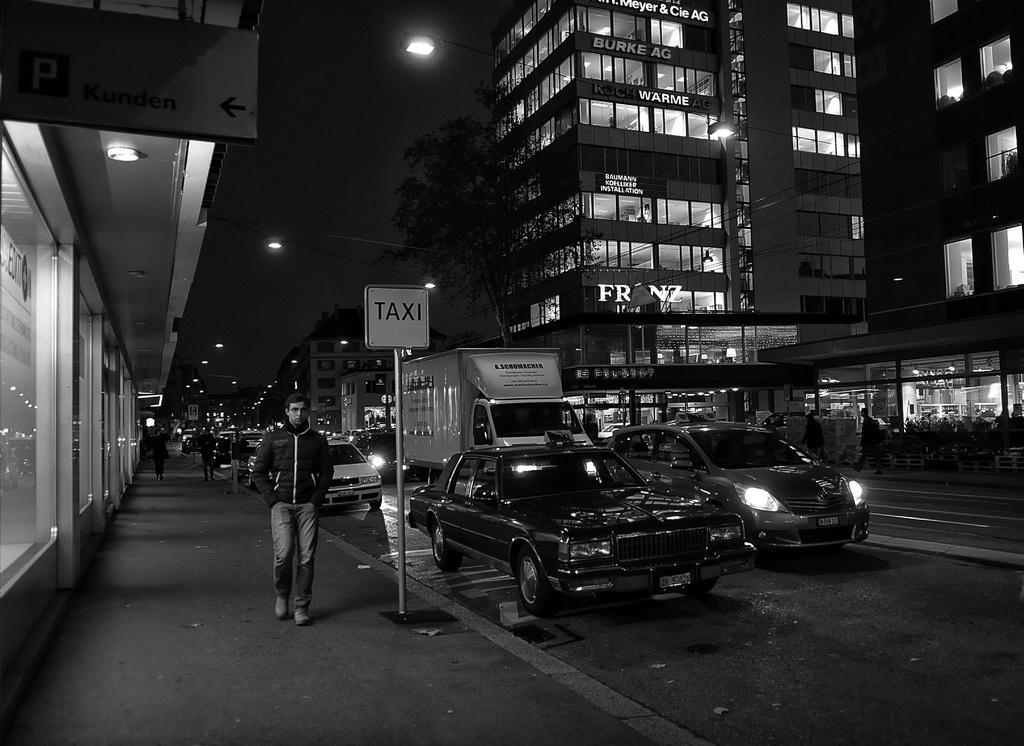Describe this image in one or two sentences. This is an outside view of the city, in this image in the center there are some vehicles on the road. On the right side and left side there are some buildings, trees, lights and some persons are walking on a footpath. On the top there are some street lights. 